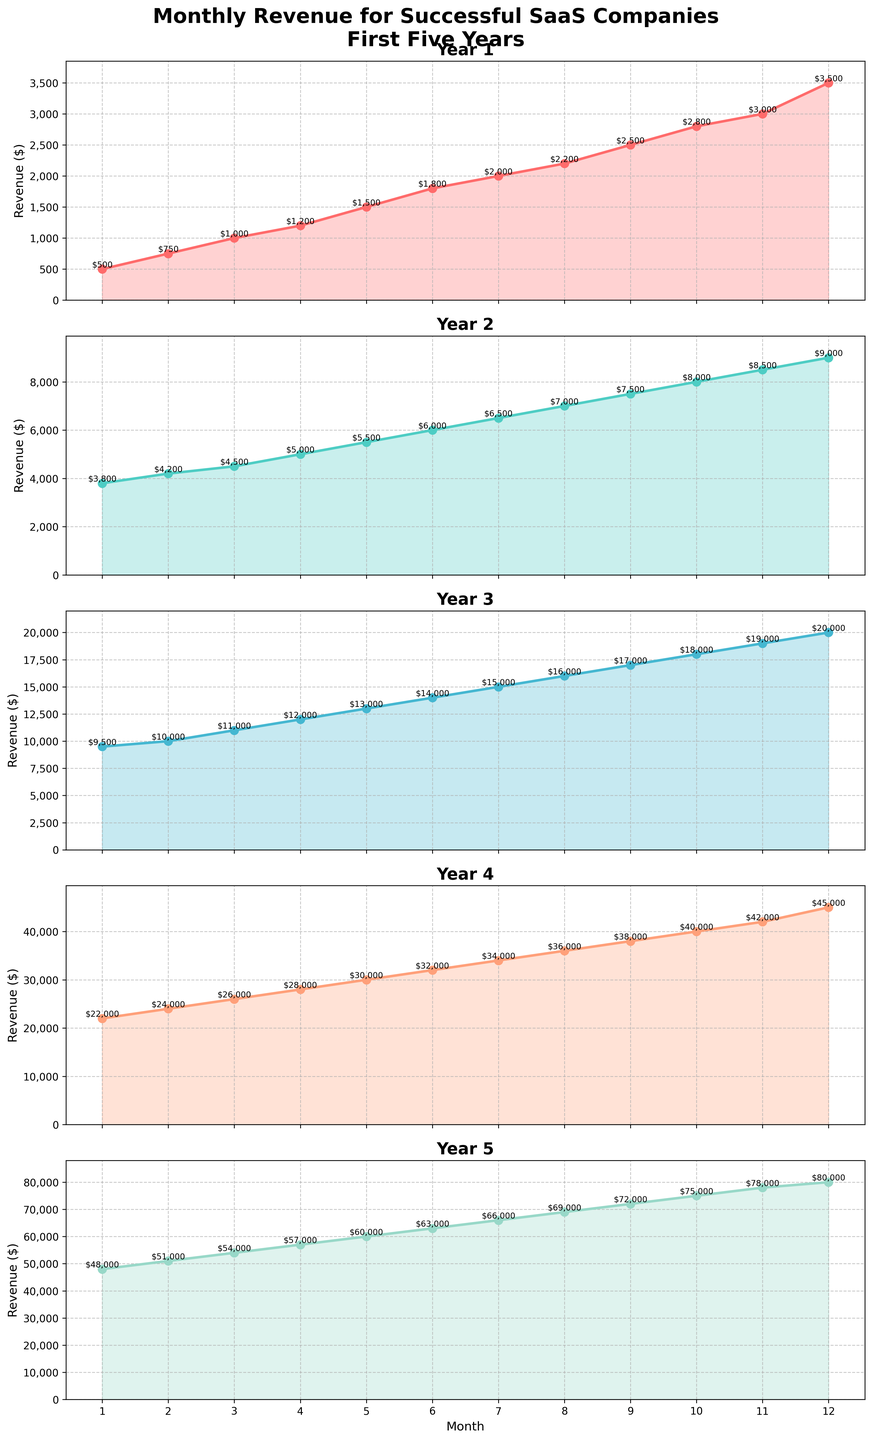what is the highest monthly revenue achieved in the fifth year? In the fifth subplot labeled "Year 5", look for the highest point on the line. The peak revenue value of $80,000 is in December (Month 12), which is clearly shown at the end of the line plot.
Answer: $80,000 Which year showed the greatest increase in monthly revenue from January to December? Compare the start and end points of the line plots in each subplot. Year 5 starts with $48,000 in January and ends with $80,000 in December, showing the largest increase of $32,000.
Answer: Year 5 In which month of the third year did the revenue first exceed $15,000? In the third subplot labeled "Year 3", locate the point on the line where the revenue first surpasses $15,000. This transition happens between July ($15,000) and August ($16,000). Therefore, the revenue first exceeds $15,000 in August.
Answer: August (Month 8) Calculate the average monthly revenue for Year 2. To find the average, sum the monthly revenue values for Year 2 and divide by 12. Revenue from January to December in Year 2 adds up to $6,900 x 12 = $81,000. Dividing by 12 gives an average monthly revenue of $6,750.
Answer: $6,750 Which year shows the least overall fluctuation in monthly revenue? Examine the line plots and identify the year with the smallest differences between the highest and lowest revenue points. Year 4 shows a steady incremental increase with smaller gaps compared to other years.
Answer: Year 4 How does the monthly revenue trend from Year 1 compare to Year 3? Visually, Year 1 has a more gradual slope and steady growth compared to Year 3, which demonstrates a steeper incline, indicating a faster growth rate in revenue.
Answer: Year 3 shows faster growth If the growth trend from Year 3 continues into Year 4, what would be the expected revenue for January of Year 4? Year 3 ends at $20,000 in December (Month 12). Extrapolating the steep growth trend into Year 4, January’s revenue could reasonably be expected to be around the next higher value observed in the plot series, which matches closer to $22,000.
Answer: $22,000 